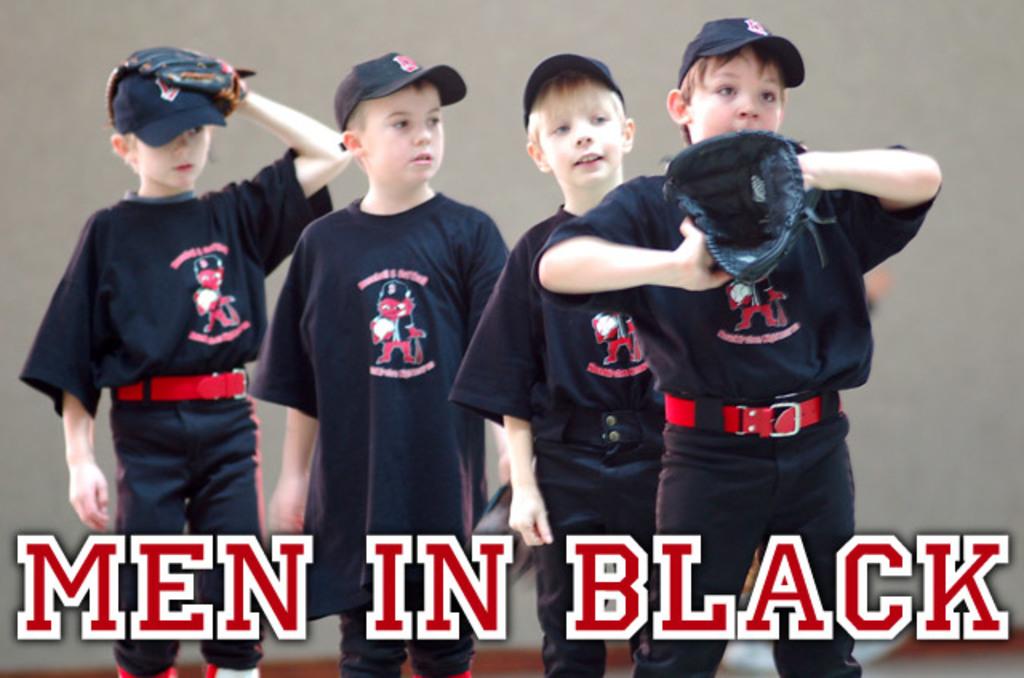What is the team of boys' name?
Give a very brief answer. Men in black. What color are the boys wearing?
Your answer should be very brief. Answering does not require reading text in the image. 